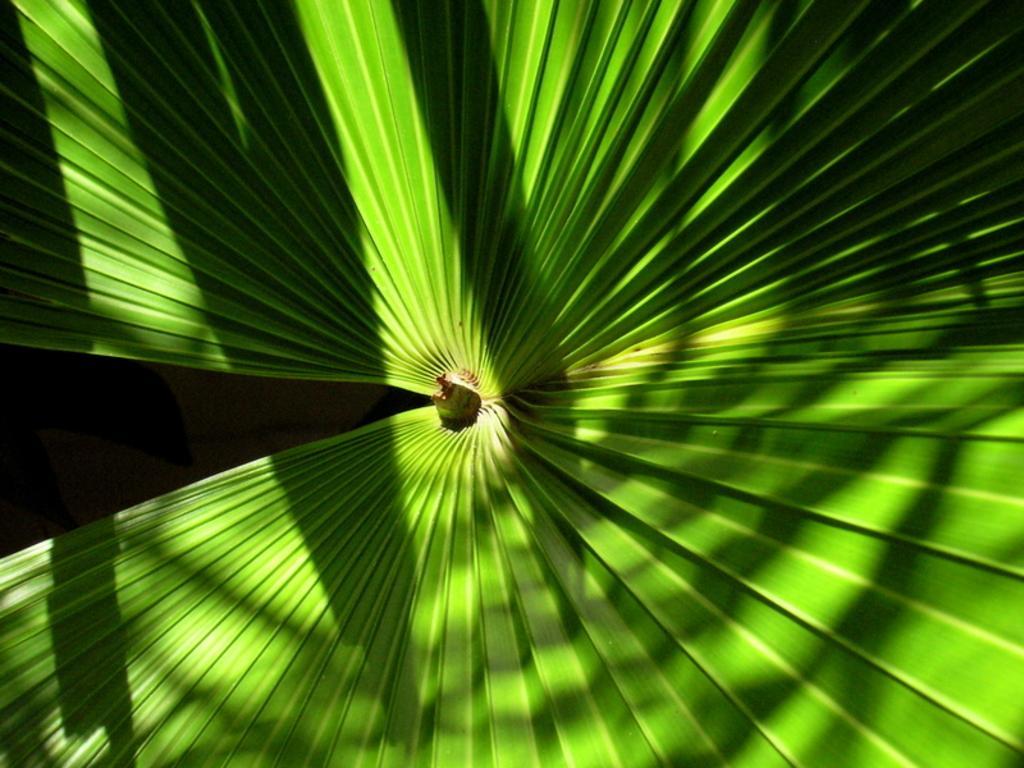Can you describe this image briefly? In this image we can see the leaf of a plant. 